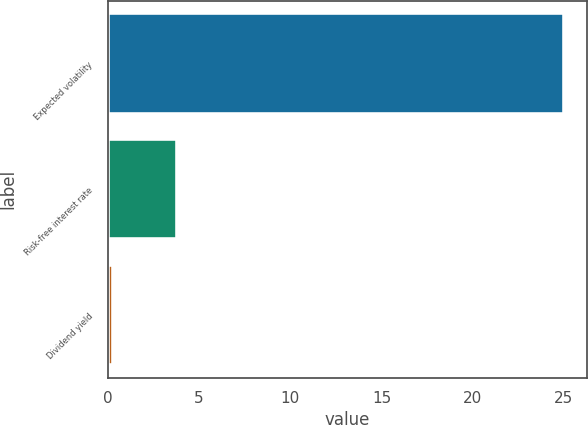Convert chart to OTSL. <chart><loc_0><loc_0><loc_500><loc_500><bar_chart><fcel>Expected volatility<fcel>Risk-free interest rate<fcel>Dividend yield<nl><fcel>25<fcel>3.79<fcel>0.32<nl></chart> 